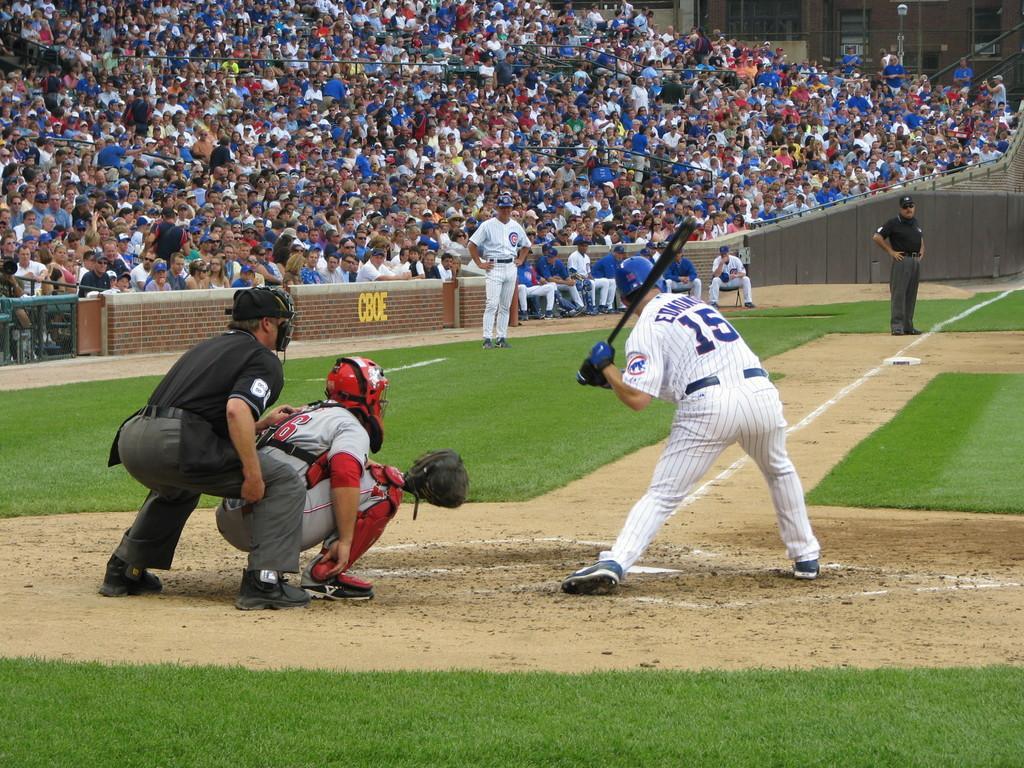How would you summarize this image in a sentence or two? In this picture we can see a group of people standing and two persons are in squat position. Behind the people there are groups of people sitting. 